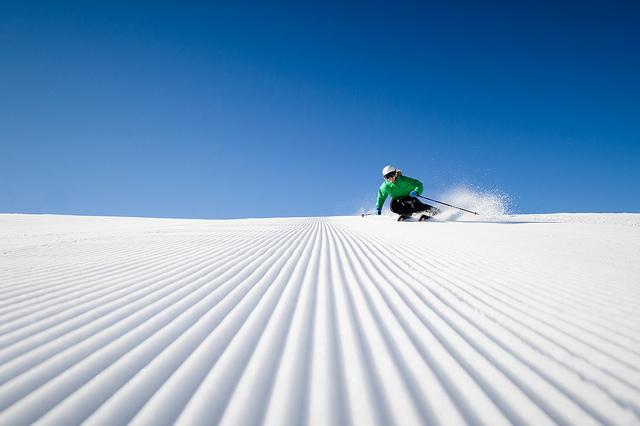How many people are in this photo?
Give a very brief answer. 1. Where are the skier?
Quick response, please. On snow. Are those perfectly straight lines?
Short answer required. Yes. What is the person doing?
Quick response, please. Skiing. 